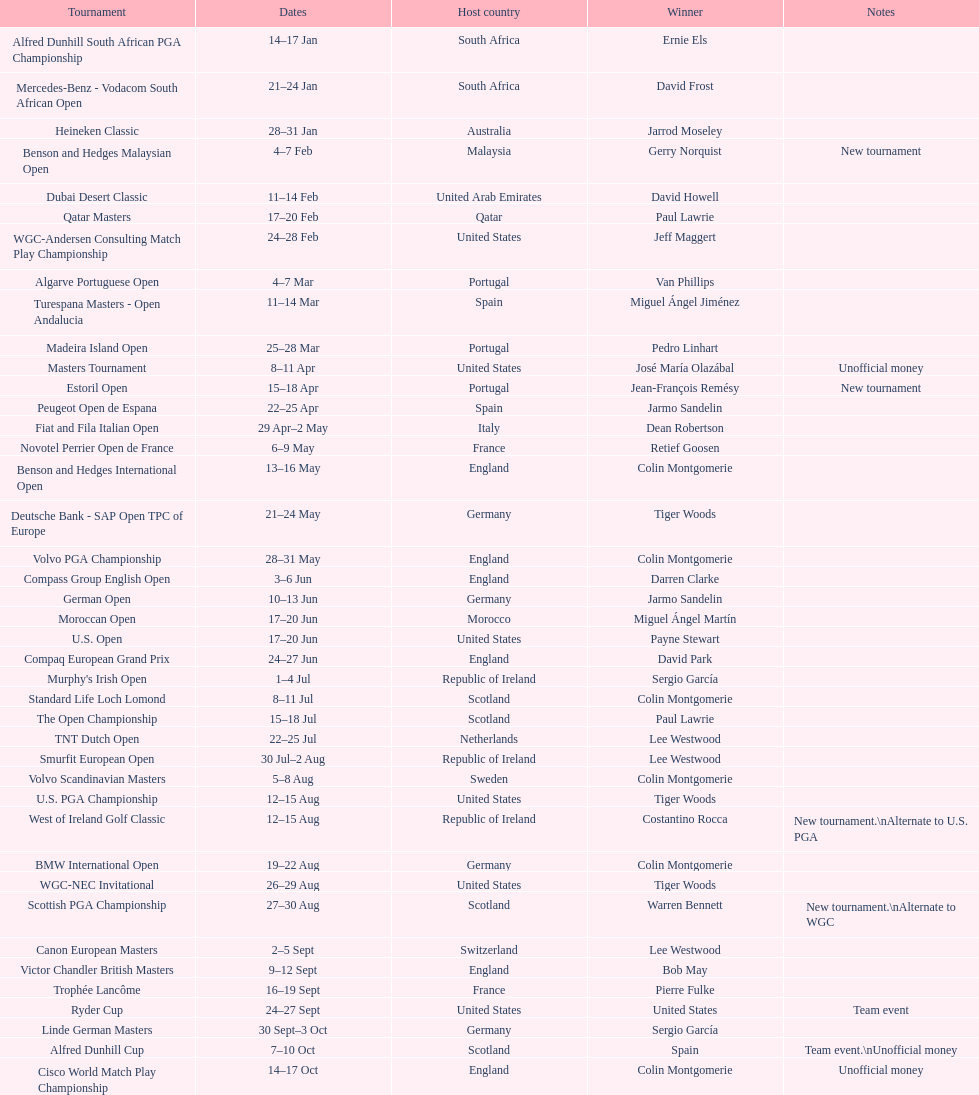What was the country listed the first time there was a new tournament? Malaysia. 